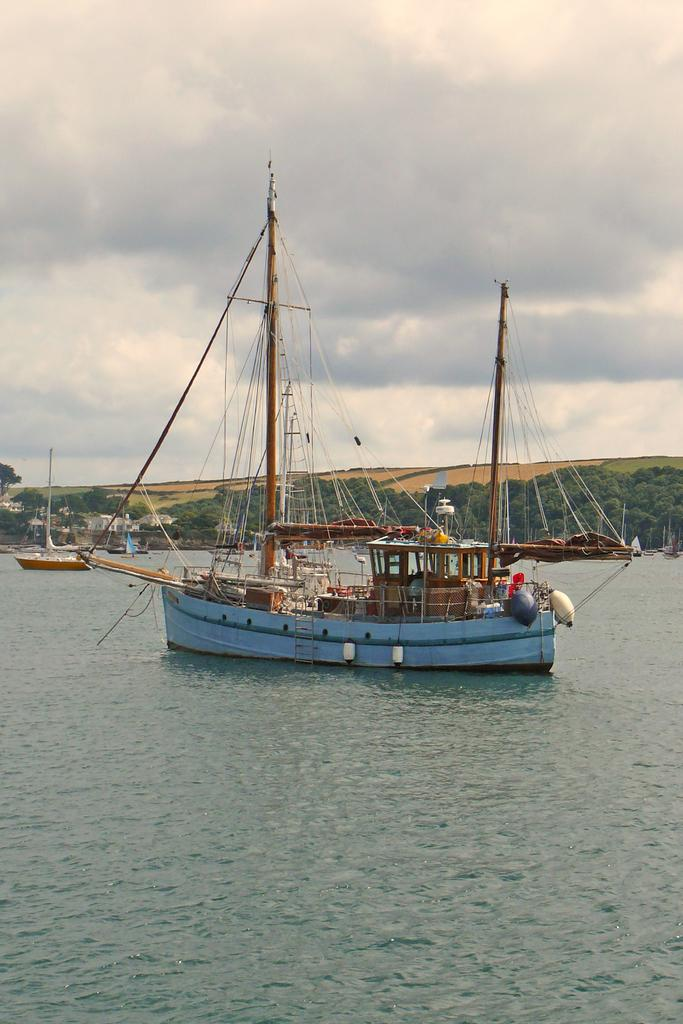What is the primary element in the image? There is water in the image. What is on the water in the image? There are boats on the water. What can be seen in the background of the image? There are mountains and trees in the background of the image. What is visible at the top of the image? The sky is visible at the top of the image. What type of furniture can be seen in the image? There is no furniture present in the image; it features water, boats, mountains, trees, and the sky. 